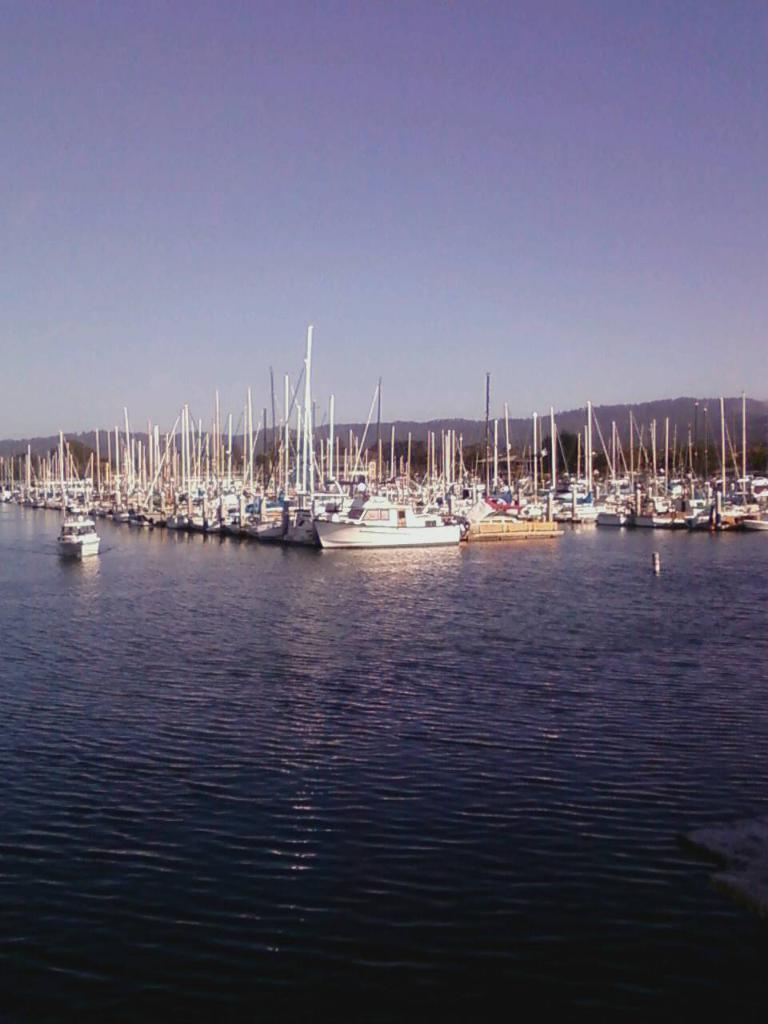What is the main subject of the image? The main subject of the image is multiple ships. How are the ships arranged in the image? The ships are gathered in one place. How many cakes are on each ship in the image? There are no cakes present in the image; it features multiple ships gathered in one place. 